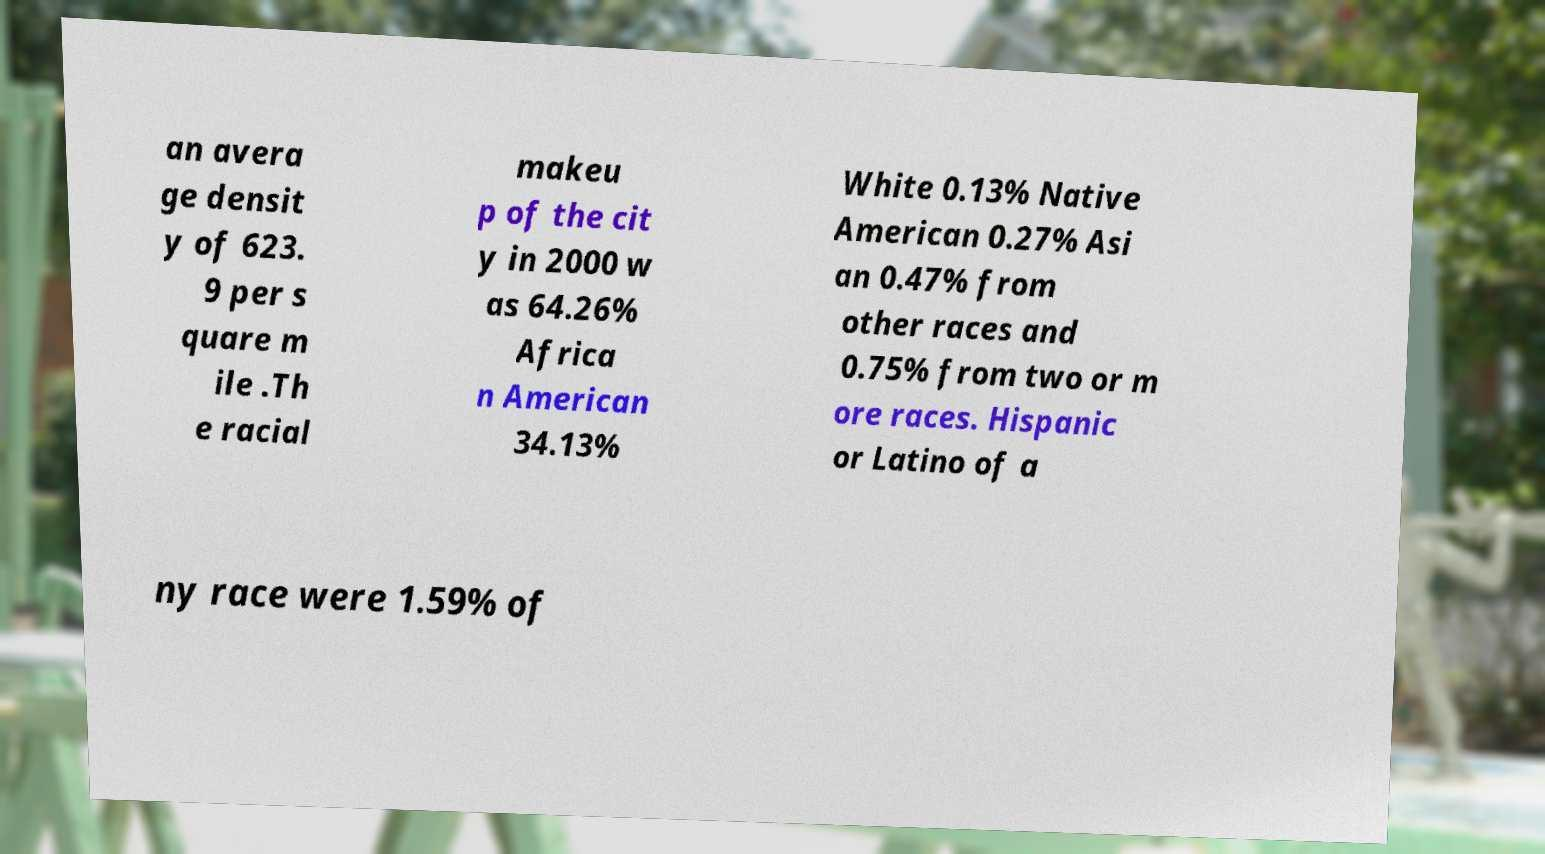Can you read and provide the text displayed in the image?This photo seems to have some interesting text. Can you extract and type it out for me? an avera ge densit y of 623. 9 per s quare m ile .Th e racial makeu p of the cit y in 2000 w as 64.26% Africa n American 34.13% White 0.13% Native American 0.27% Asi an 0.47% from other races and 0.75% from two or m ore races. Hispanic or Latino of a ny race were 1.59% of 